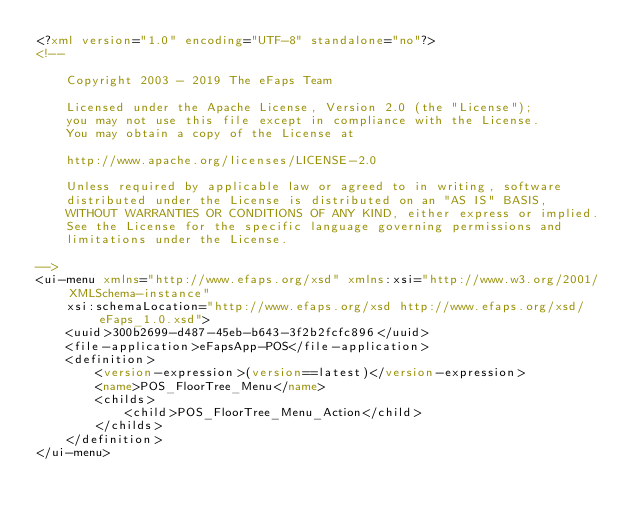<code> <loc_0><loc_0><loc_500><loc_500><_XML_><?xml version="1.0" encoding="UTF-8" standalone="no"?>
<!--

    Copyright 2003 - 2019 The eFaps Team

    Licensed under the Apache License, Version 2.0 (the "License");
    you may not use this file except in compliance with the License.
    You may obtain a copy of the License at

    http://www.apache.org/licenses/LICENSE-2.0

    Unless required by applicable law or agreed to in writing, software
    distributed under the License is distributed on an "AS IS" BASIS,
    WITHOUT WARRANTIES OR CONDITIONS OF ANY KIND, either express or implied.
    See the License for the specific language governing permissions and
    limitations under the License.

-->
<ui-menu xmlns="http://www.efaps.org/xsd" xmlns:xsi="http://www.w3.org/2001/XMLSchema-instance"
    xsi:schemaLocation="http://www.efaps.org/xsd http://www.efaps.org/xsd/eFaps_1.0.xsd">
    <uuid>300b2699-d487-45eb-b643-3f2b2fcfc896</uuid>
    <file-application>eFapsApp-POS</file-application>
    <definition>
        <version-expression>(version==latest)</version-expression>
        <name>POS_FloorTree_Menu</name>
        <childs>
            <child>POS_FloorTree_Menu_Action</child>
        </childs>
    </definition>
</ui-menu>
</code> 